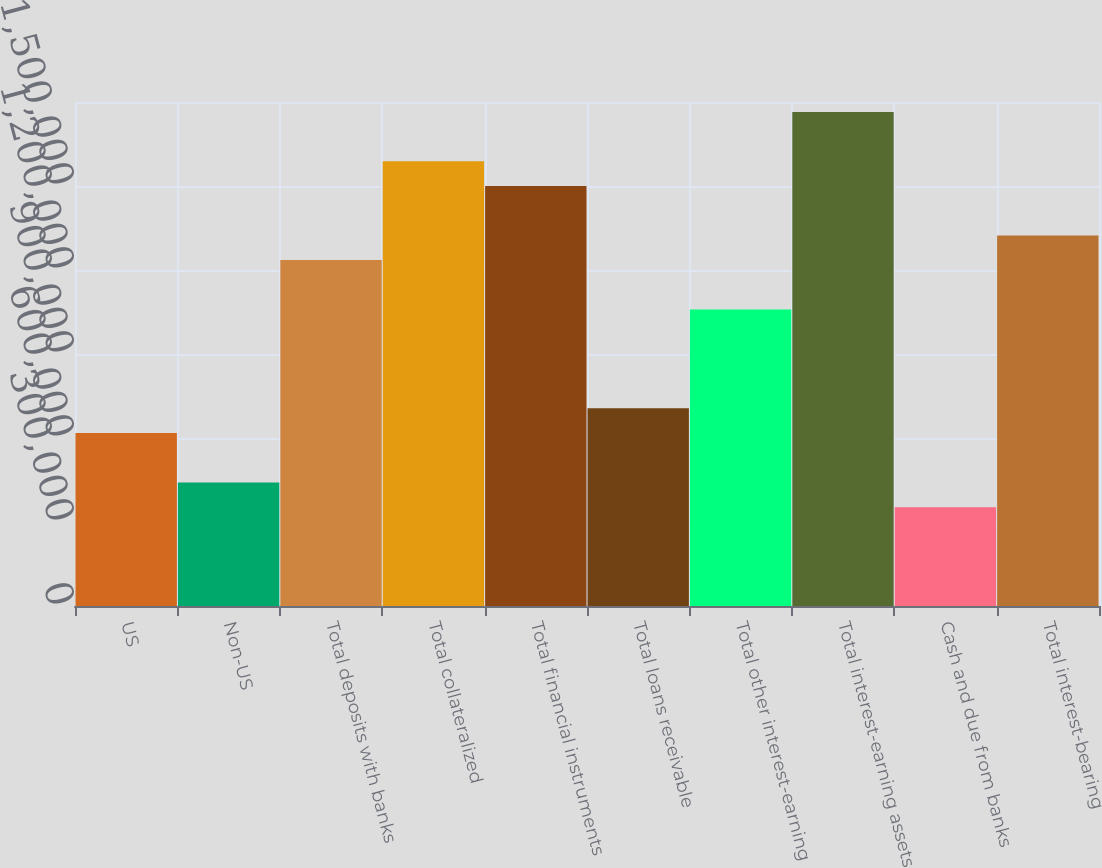<chart> <loc_0><loc_0><loc_500><loc_500><bar_chart><fcel>US<fcel>Non-US<fcel>Total deposits with banks<fcel>Total collateralized<fcel>Total financial instruments<fcel>Total loans receivable<fcel>Total other interest-earning<fcel>Total interest-earning assets<fcel>Cash and due from banks<fcel>Total interest-bearing<nl><fcel>617649<fcel>441186<fcel>1.23527e+06<fcel>1.58819e+06<fcel>1.49996e+06<fcel>705880<fcel>1.05881e+06<fcel>1.76466e+06<fcel>352954<fcel>1.3235e+06<nl></chart> 